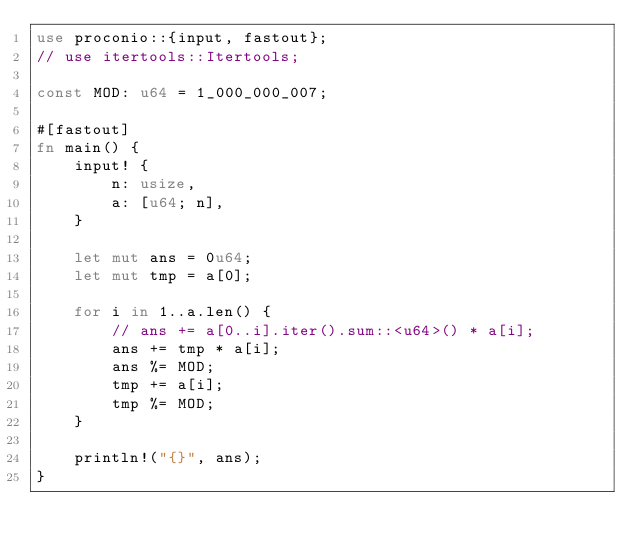<code> <loc_0><loc_0><loc_500><loc_500><_Rust_>use proconio::{input, fastout};
// use itertools::Itertools;

const MOD: u64 = 1_000_000_007;

#[fastout]
fn main() {
    input! {
        n: usize,
        a: [u64; n],
    }

    let mut ans = 0u64;
    let mut tmp = a[0];

    for i in 1..a.len() {
        // ans += a[0..i].iter().sum::<u64>() * a[i];
        ans += tmp * a[i];
        ans %= MOD;
        tmp += a[i];
        tmp %= MOD;
    }

    println!("{}", ans);
}
</code> 